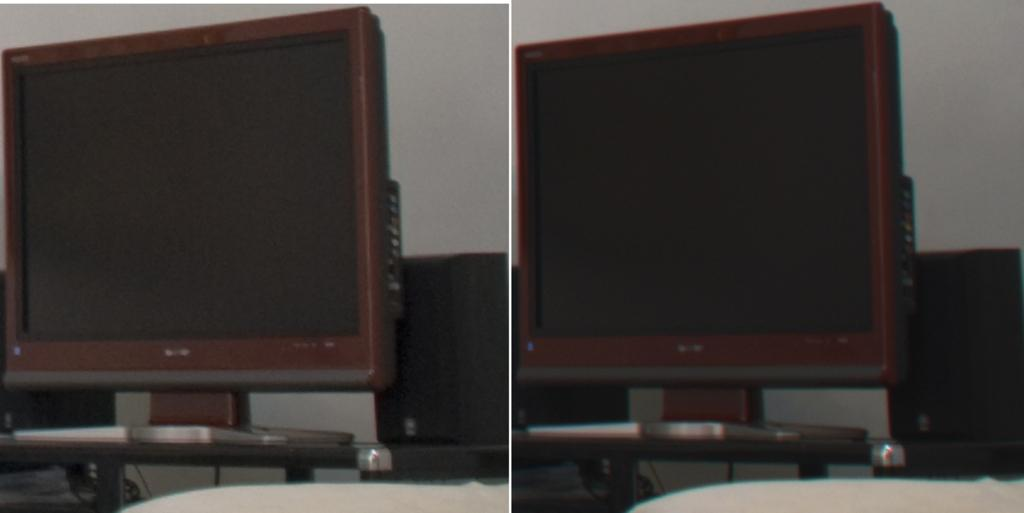What type of image is being described? The image is a collage. What objects can be seen on the tables in the image? There are monitors and speakers on tables in the image. What is visible in the background of the image? There is a wall visible in the image. What type of plate is being used to serve the celery in the image? There is no plate or celery present in the image. Can you describe the robin's nest in the image? There is no robin or nest present in the image. 